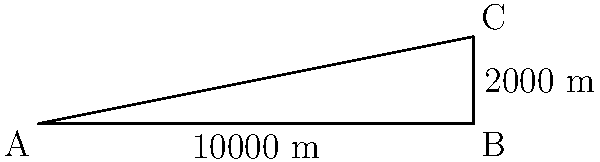A historical emergency landing strip in Iran is depicted on a topographical map. The strip starts at point A and ends at point B, covering a horizontal distance of 10,000 meters. Point C represents the highest point of the terrain, located 2,000 meters above point B. What is the angle of descent (θ) for an aircraft approaching this landing strip from point C to point B? To find the angle of descent (θ), we need to use trigonometry. We can treat this scenario as a right-angled triangle where:

1. The horizontal distance from A to B is the base of the triangle (adjacent to θ).
2. The vertical distance from B to C is the height of the triangle (opposite to θ).
3. The line from C to B represents the flight path (hypotenuse).

We can use the tangent function to calculate θ:

$$ \tan(\theta) = \frac{\text{opposite}}{\text{adjacent}} = \frac{\text{height}}{\text{base}} $$

Substituting the values:

$$ \tan(\theta) = \frac{2000 \text{ m}}{10000 \text{ m}} = \frac{1}{5} = 0.2 $$

To find θ, we need to take the inverse tangent (arctan or tan⁻¹):

$$ \theta = \tan^{-1}(0.2) $$

Using a calculator or trigonometric tables:

$$ \theta \approx 11.31° $$

This angle represents the descent angle from point C to point B.
Answer: 11.31° 